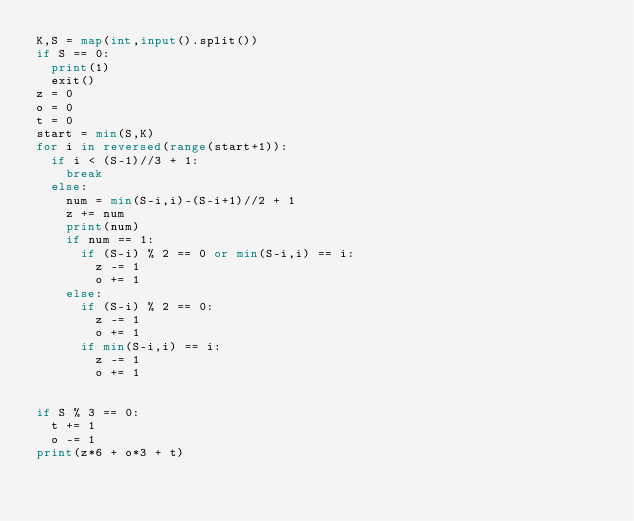<code> <loc_0><loc_0><loc_500><loc_500><_Python_>K,S = map(int,input().split())
if S == 0:
  print(1)
  exit()
z = 0
o = 0
t = 0
start = min(S,K)
for i in reversed(range(start+1)):
  if i < (S-1)//3 + 1:
    break
  else:
    num = min(S-i,i)-(S-i+1)//2 + 1
    z += num
    print(num)
    if num == 1:
      if (S-i) % 2 == 0 or min(S-i,i) == i:
        z -= 1
        o += 1
    else:
      if (S-i) % 2 == 0:
        z -= 1
        o += 1
      if min(S-i,i) == i:
        z -= 1
        o += 1
        
      
if S % 3 == 0:
  t += 1
  o -= 1
print(z*6 + o*3 + t)</code> 